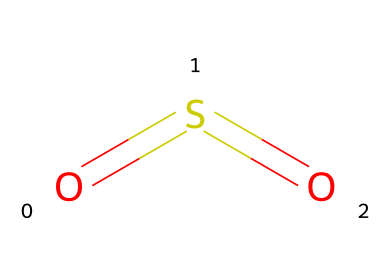What is the molecular formula of this compound? The structure shows one sulfur (S) atom and two oxygen (O) atoms, indicated by the arrangement of elements in the SMILES representation. Therefore, the molecular formula is derived directly from counting these atoms.
Answer: SO2 How many double bonds are in the structure of sulfur dioxide? The SMILES notation shows sulfur (S) connected to two oxygen (O) atoms through double bonds, as indicated by the '=' sign connecting them. Thus, there are two double bonds present in the structure.
Answer: 2 What is the main function of sulfur dioxide in food preservation? Sulfur dioxide acts as a preservative by inhibiting microbial growth and preventing oxidation, which helps to preserve food freshness and color. This is a key aspect of its use in food.
Answer: preservative What type of bonding is primarily present in sulfur dioxide? The bonds between sulfur and oxygen in SO2 are characterized as covalent bonds. Covalent bonding involves the sharing of electrons, which defines the interactions seen in this molecular structure.
Answer: covalent Is sulfur dioxide a gas at room temperature? Sulfur dioxide is indeed classified as a gas at room temperature, as it exists in gaseous form when not subjected to high pressure or low temperature conditions.
Answer: yes 